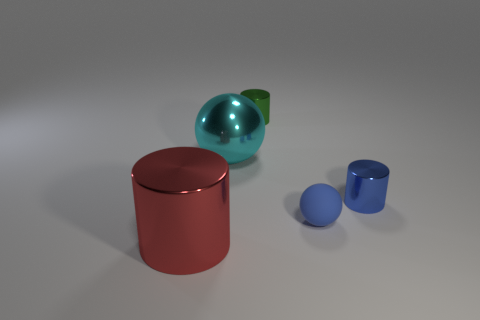How many tiny purple metal things are there?
Your response must be concise. 0. Is the color of the thing that is on the right side of the tiny matte ball the same as the big object on the left side of the cyan thing?
Your response must be concise. No. There is a cylinder that is the same color as the rubber ball; what size is it?
Your answer should be very brief. Small. What number of other objects are there of the same size as the blue sphere?
Provide a short and direct response. 2. There is a tiny metallic object behind the cyan metal ball; what color is it?
Make the answer very short. Green. Does the large thing that is to the right of the red cylinder have the same material as the green thing?
Offer a very short reply. Yes. What number of big objects are both behind the tiny blue metallic cylinder and in front of the rubber object?
Provide a short and direct response. 0. The thing to the left of the big thing right of the thing in front of the tiny blue matte ball is what color?
Give a very brief answer. Red. How many other objects are there of the same shape as the red shiny object?
Offer a terse response. 2. Is there a tiny blue sphere that is right of the blue object that is right of the small blue matte thing?
Provide a succinct answer. No. 